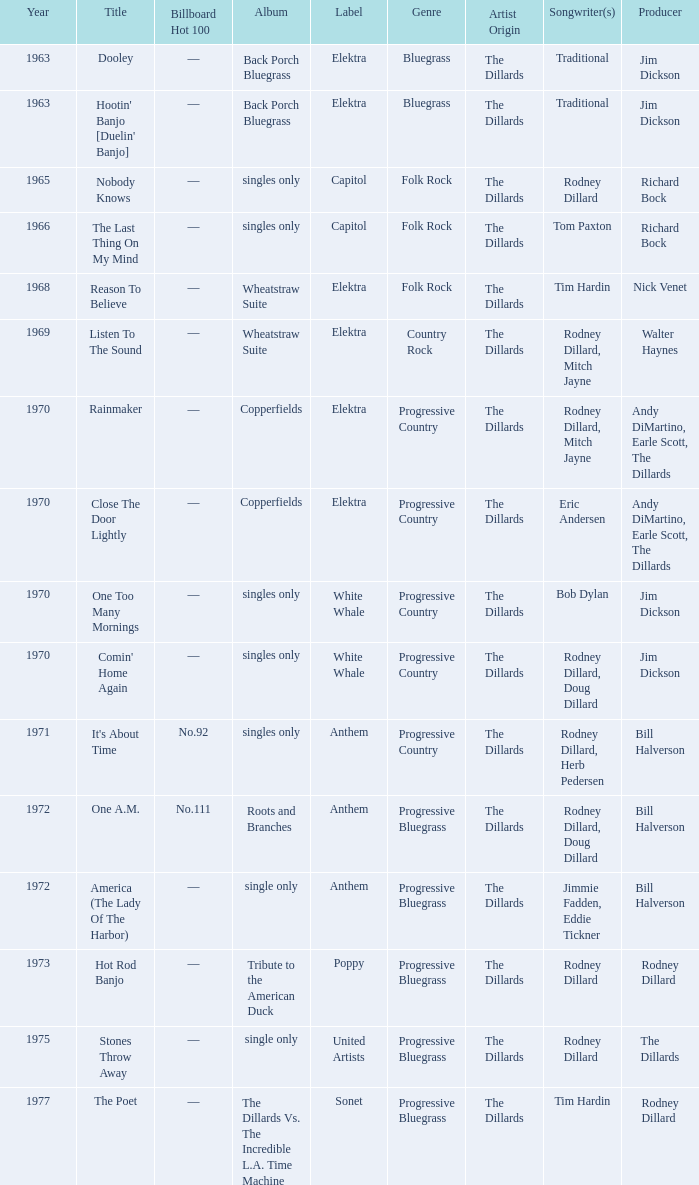What is the total years for roots and branches? 1972.0. 